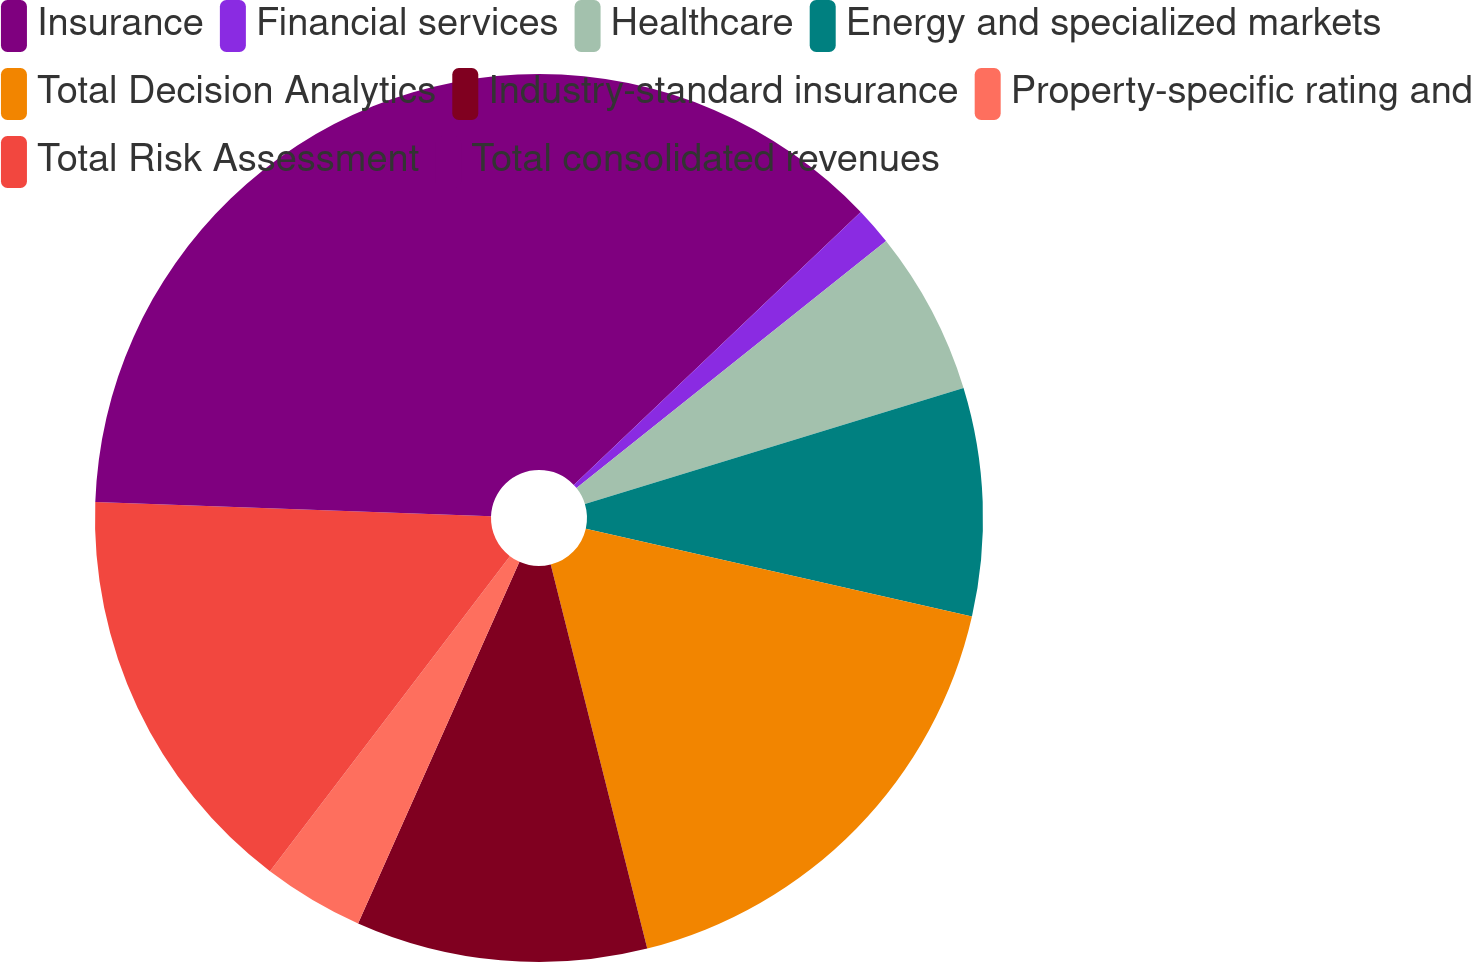Convert chart to OTSL. <chart><loc_0><loc_0><loc_500><loc_500><pie_chart><fcel>Insurance<fcel>Financial services<fcel>Healthcare<fcel>Energy and specialized markets<fcel>Total Decision Analytics<fcel>Industry-standard insurance<fcel>Property-specific rating and<fcel>Total Risk Assessment<fcel>Total consolidated revenues<nl><fcel>12.9%<fcel>1.38%<fcel>5.99%<fcel>8.29%<fcel>17.52%<fcel>10.6%<fcel>3.68%<fcel>15.21%<fcel>24.43%<nl></chart> 